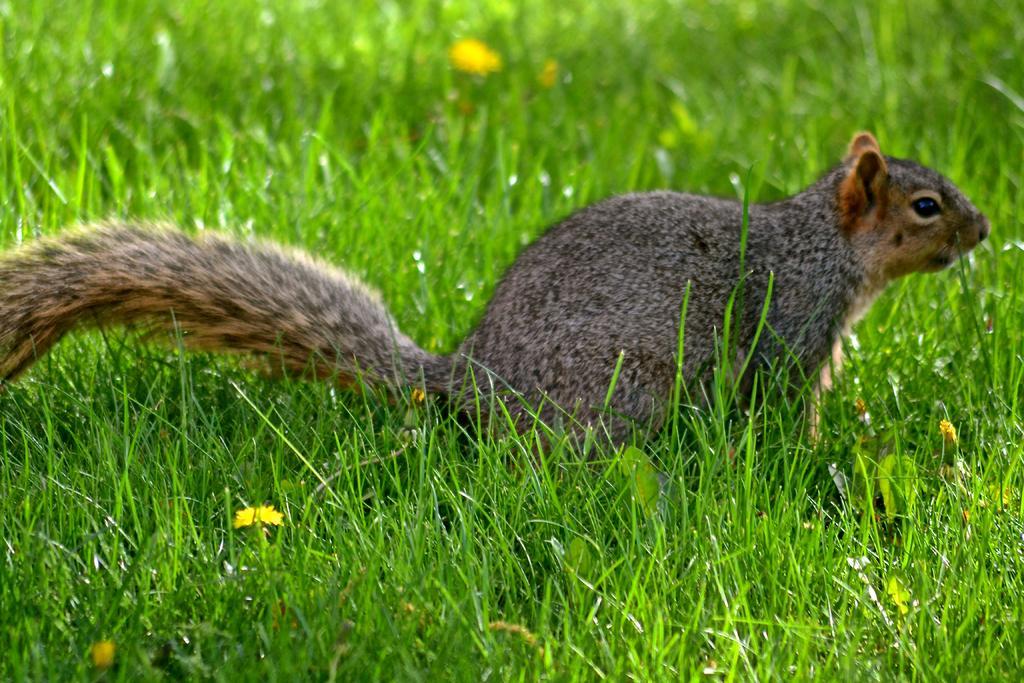In one or two sentences, can you explain what this image depicts? In this image, we can see an animal on the grass and there are some flowers. 